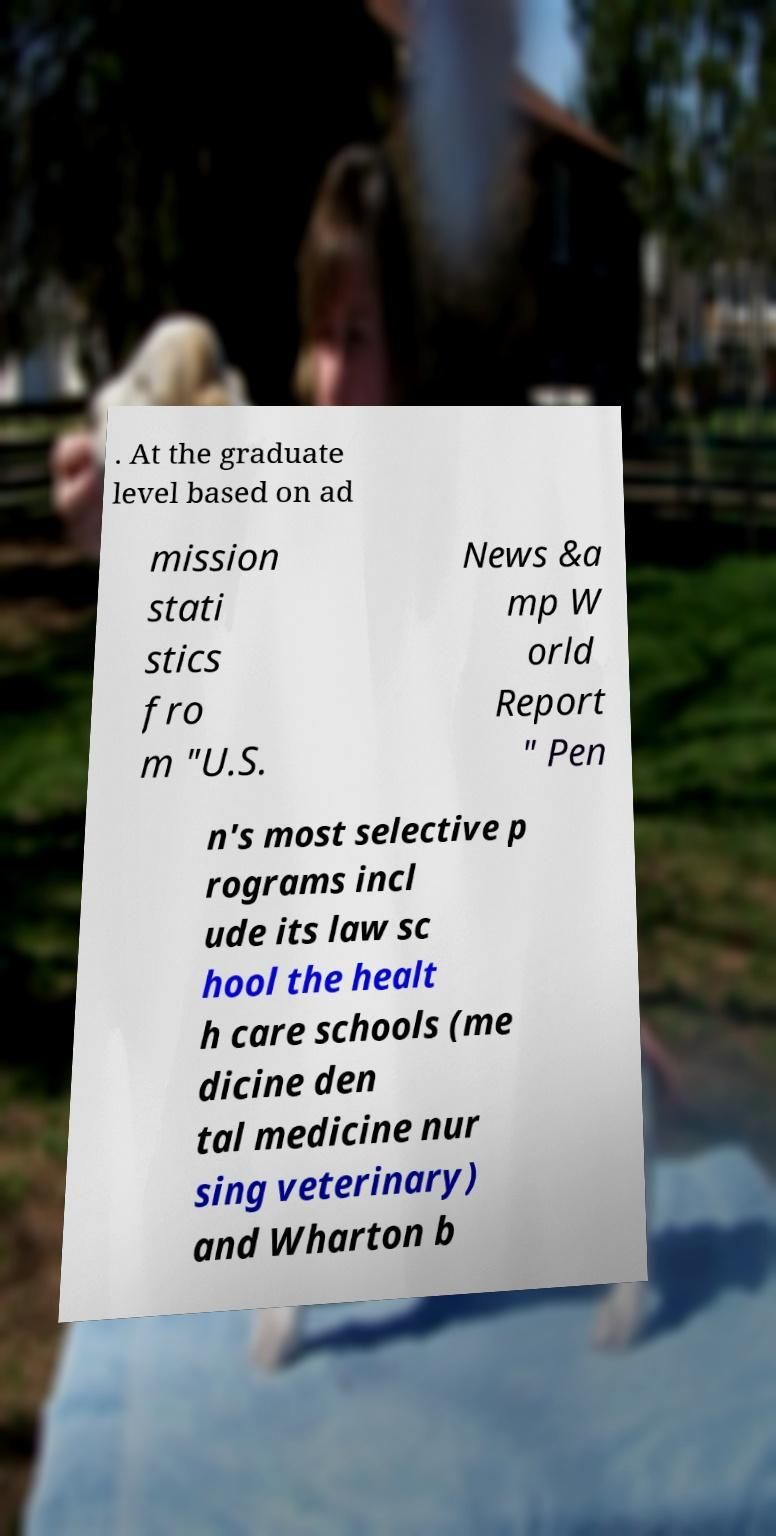Please identify and transcribe the text found in this image. . At the graduate level based on ad mission stati stics fro m "U.S. News &a mp W orld Report " Pen n's most selective p rograms incl ude its law sc hool the healt h care schools (me dicine den tal medicine nur sing veterinary) and Wharton b 